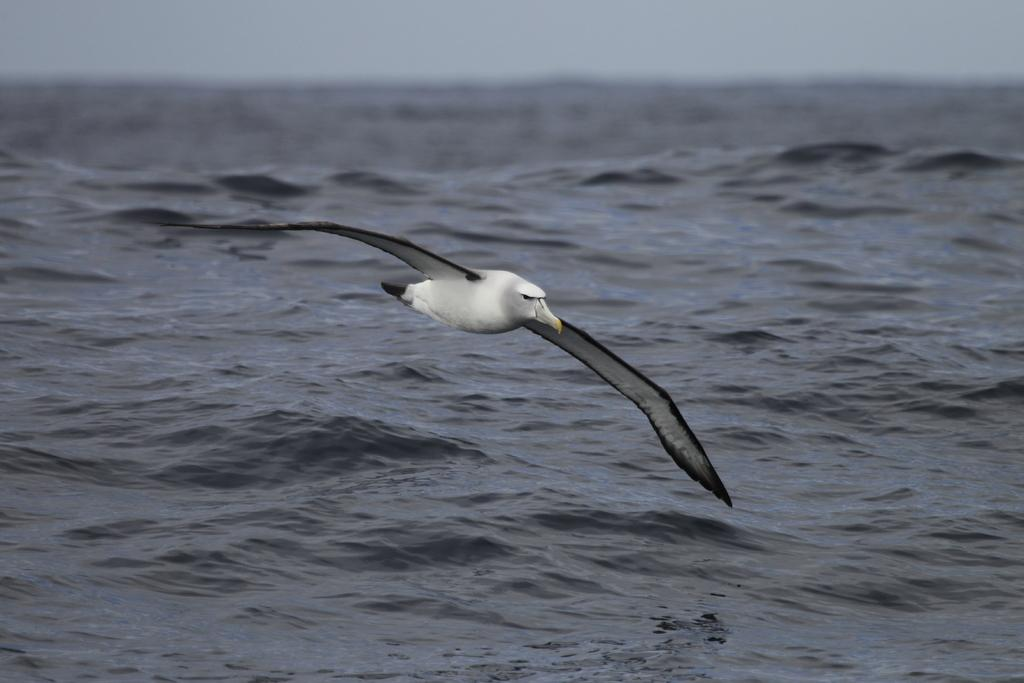What type of animal is in the image? There is a bird in the image. What color is the bird? The bird is in black and white color. What is the bird doing in the image? The bird is flying. What can be seen in the background of the image? There is water visible in the image. How much payment is the bird receiving for its performance in the image? There is no payment or performance involved in the image; it simply shows a bird flying. 